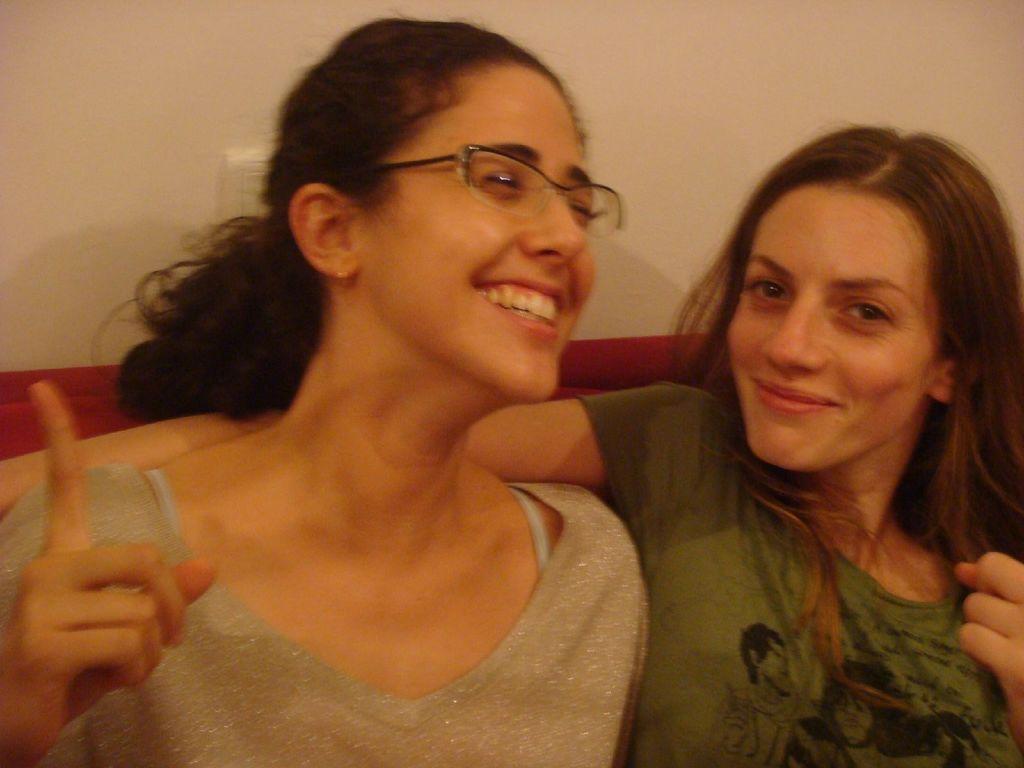How would you summarize this image in a sentence or two? In the center of the image we can see two ladies sitting. The lady sitting on the left is wearing glasses. In the background there is a wall. 